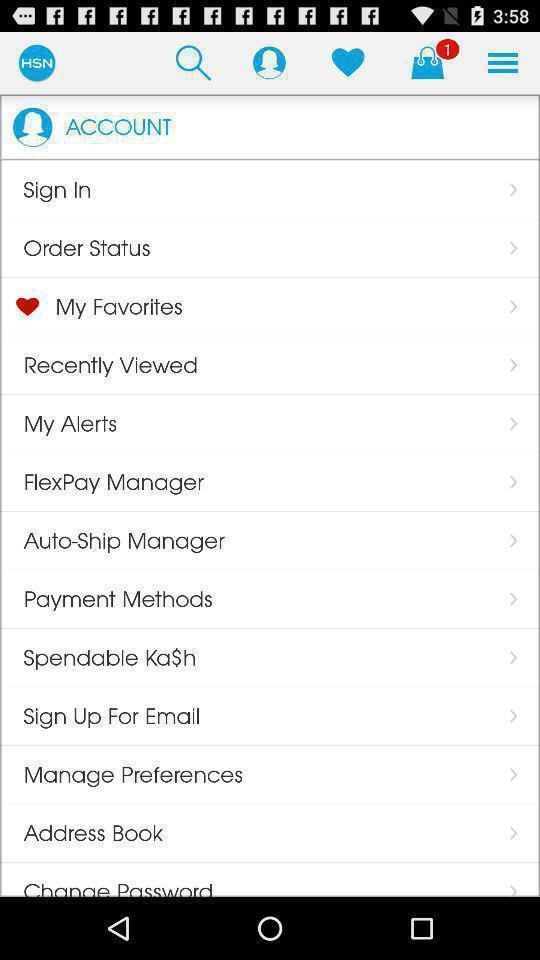Describe the visual elements of this screenshot. Page showing various options of app. 